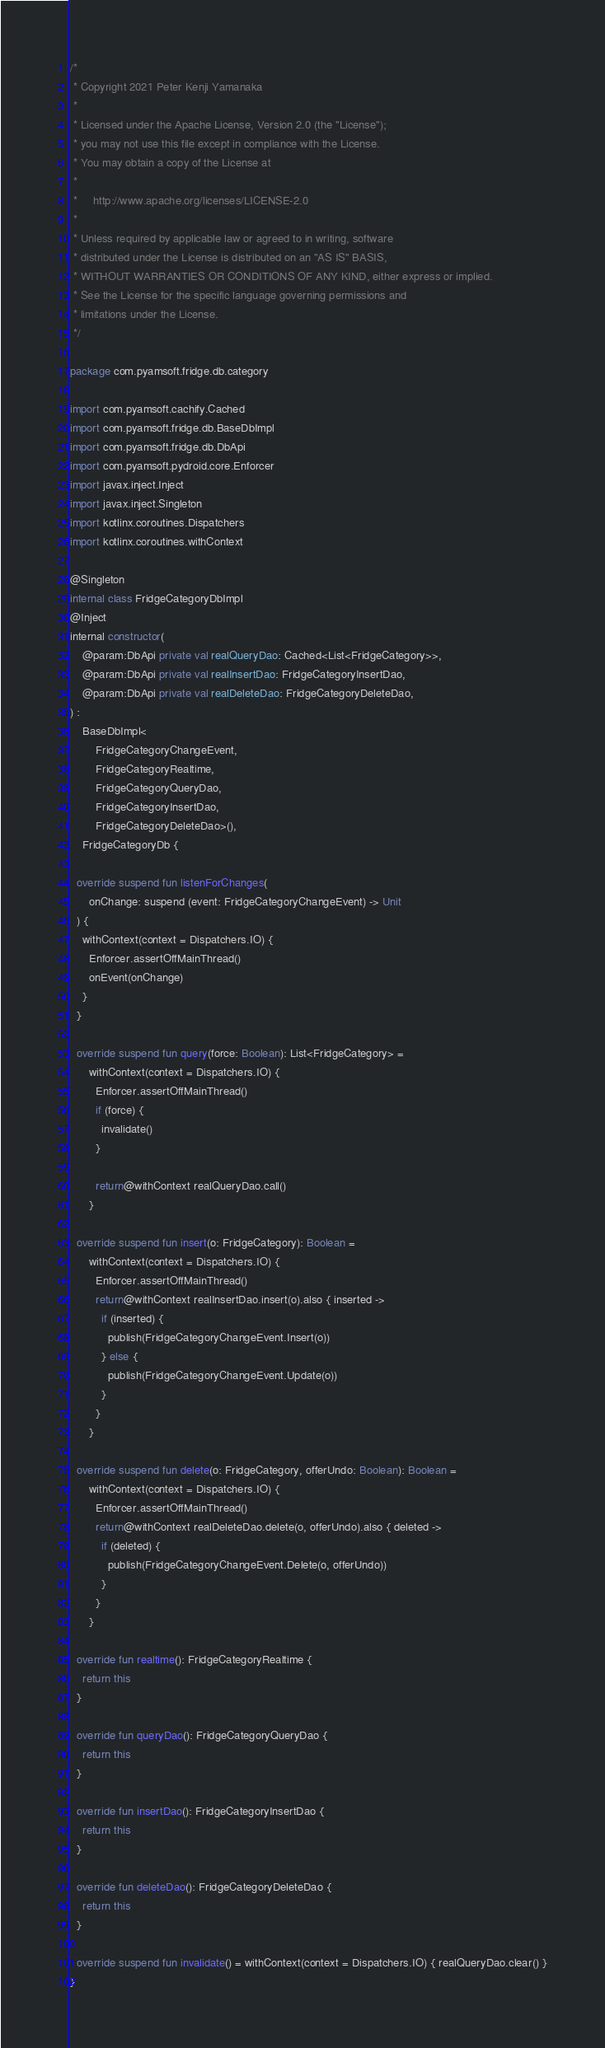Convert code to text. <code><loc_0><loc_0><loc_500><loc_500><_Kotlin_>/*
 * Copyright 2021 Peter Kenji Yamanaka
 *
 * Licensed under the Apache License, Version 2.0 (the "License");
 * you may not use this file except in compliance with the License.
 * You may obtain a copy of the License at
 *
 *     http://www.apache.org/licenses/LICENSE-2.0
 *
 * Unless required by applicable law or agreed to in writing, software
 * distributed under the License is distributed on an "AS IS" BASIS,
 * WITHOUT WARRANTIES OR CONDITIONS OF ANY KIND, either express or implied.
 * See the License for the specific language governing permissions and
 * limitations under the License.
 */

package com.pyamsoft.fridge.db.category

import com.pyamsoft.cachify.Cached
import com.pyamsoft.fridge.db.BaseDbImpl
import com.pyamsoft.fridge.db.DbApi
import com.pyamsoft.pydroid.core.Enforcer
import javax.inject.Inject
import javax.inject.Singleton
import kotlinx.coroutines.Dispatchers
import kotlinx.coroutines.withContext

@Singleton
internal class FridgeCategoryDbImpl
@Inject
internal constructor(
    @param:DbApi private val realQueryDao: Cached<List<FridgeCategory>>,
    @param:DbApi private val realInsertDao: FridgeCategoryInsertDao,
    @param:DbApi private val realDeleteDao: FridgeCategoryDeleteDao,
) :
    BaseDbImpl<
        FridgeCategoryChangeEvent,
        FridgeCategoryRealtime,
        FridgeCategoryQueryDao,
        FridgeCategoryInsertDao,
        FridgeCategoryDeleteDao>(),
    FridgeCategoryDb {

  override suspend fun listenForChanges(
      onChange: suspend (event: FridgeCategoryChangeEvent) -> Unit
  ) {
    withContext(context = Dispatchers.IO) {
      Enforcer.assertOffMainThread()
      onEvent(onChange)
    }
  }

  override suspend fun query(force: Boolean): List<FridgeCategory> =
      withContext(context = Dispatchers.IO) {
        Enforcer.assertOffMainThread()
        if (force) {
          invalidate()
        }

        return@withContext realQueryDao.call()
      }

  override suspend fun insert(o: FridgeCategory): Boolean =
      withContext(context = Dispatchers.IO) {
        Enforcer.assertOffMainThread()
        return@withContext realInsertDao.insert(o).also { inserted ->
          if (inserted) {
            publish(FridgeCategoryChangeEvent.Insert(o))
          } else {
            publish(FridgeCategoryChangeEvent.Update(o))
          }
        }
      }

  override suspend fun delete(o: FridgeCategory, offerUndo: Boolean): Boolean =
      withContext(context = Dispatchers.IO) {
        Enforcer.assertOffMainThread()
        return@withContext realDeleteDao.delete(o, offerUndo).also { deleted ->
          if (deleted) {
            publish(FridgeCategoryChangeEvent.Delete(o, offerUndo))
          }
        }
      }

  override fun realtime(): FridgeCategoryRealtime {
    return this
  }

  override fun queryDao(): FridgeCategoryQueryDao {
    return this
  }

  override fun insertDao(): FridgeCategoryInsertDao {
    return this
  }

  override fun deleteDao(): FridgeCategoryDeleteDao {
    return this
  }

  override suspend fun invalidate() = withContext(context = Dispatchers.IO) { realQueryDao.clear() }
}
</code> 